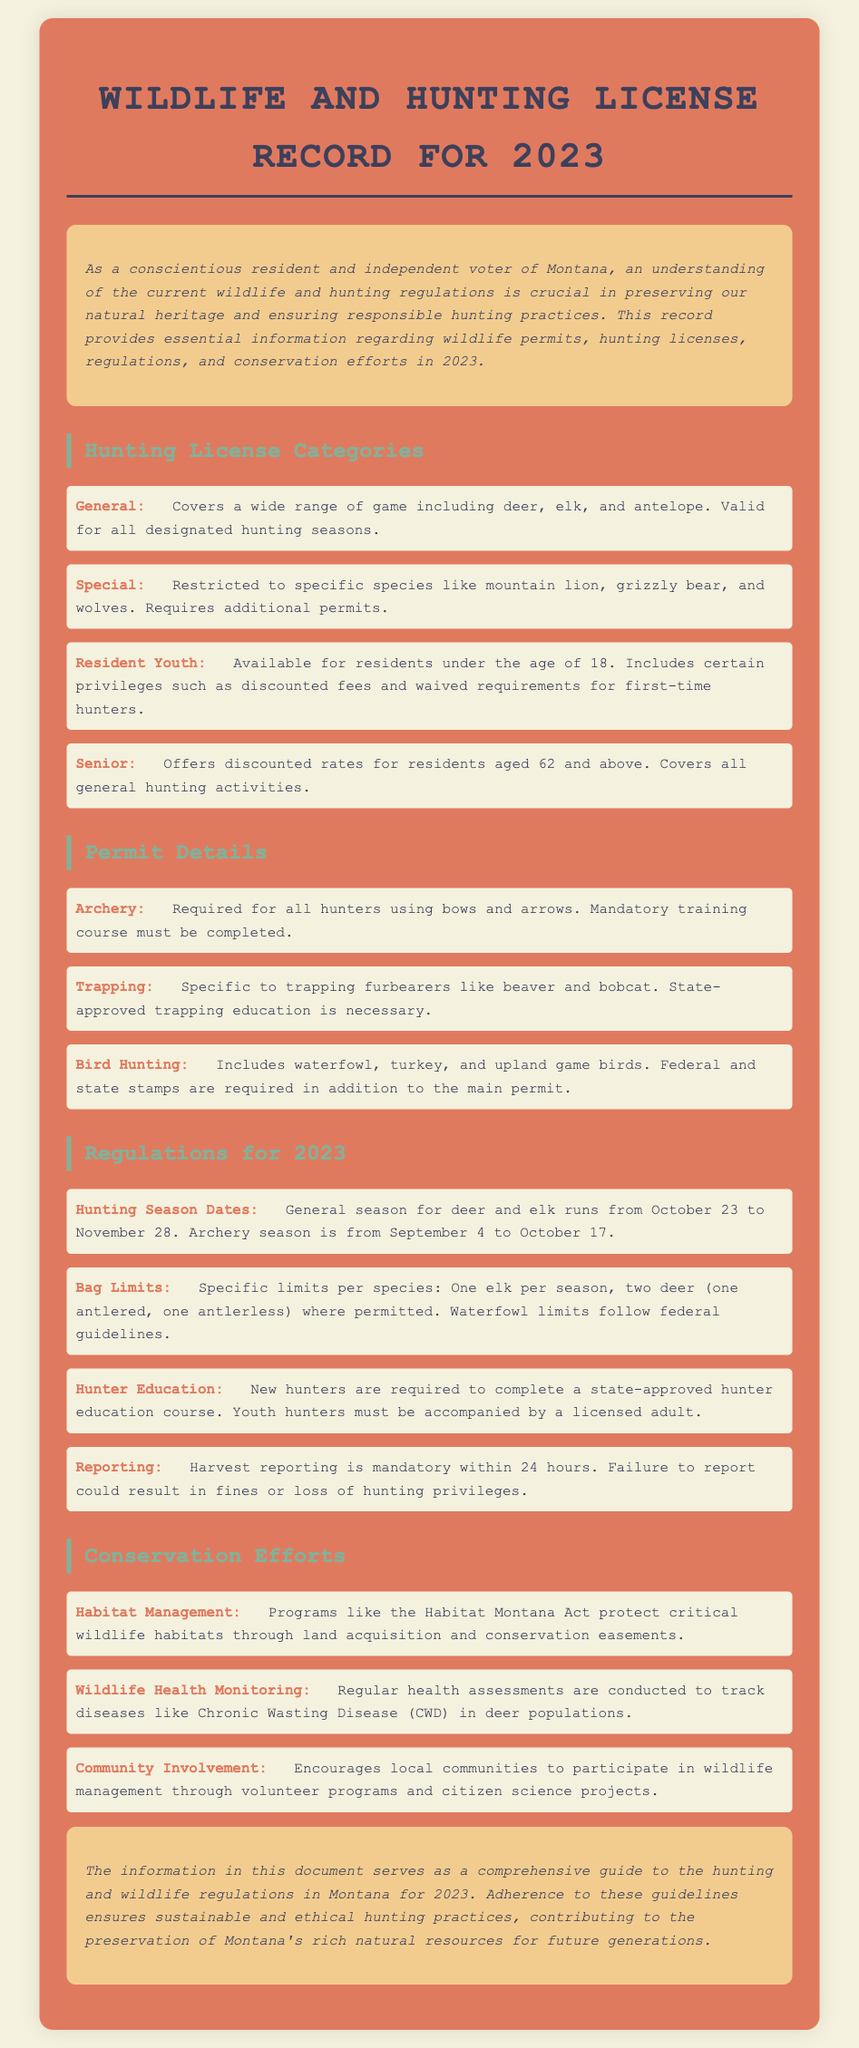What are the general hunting season dates for 2023? The general hunting season for deer and elk runs from October 23 to November 28.
Answer: October 23 to November 28 What is required for all hunters using bows and arrows? All hunters using bows and arrows are required to have an archery permit, which needs a mandatory training course.
Answer: Archery permit How many deer can be harvested per season? The document states that the bag limit allows for two deer per season, one antlered and one antlerless where permitted.
Answer: Two deer What initiative protects critical wildlife habitats? The Habitat Montana Act is mentioned as a program that protects critical wildlife habitats.
Answer: Habitat Montana Act What is the age for a Senior hunting license discount? The discount for a Senior hunting license is available for residents aged 62 and above.
Answer: 62 What is mandatory within 24 hours of a hunt? The document specifies that harvest reporting must be completed within 24 hours after a hunt.
Answer: Harvest reporting What type of education is required for new hunters? New hunters are required to complete a state-approved hunter education course.
Answer: State-approved hunter education course What is the primary purpose of the document? The document serves as a comprehensive guide to the hunting and wildlife regulations in Montana for 2023.
Answer: Comprehensive guide 